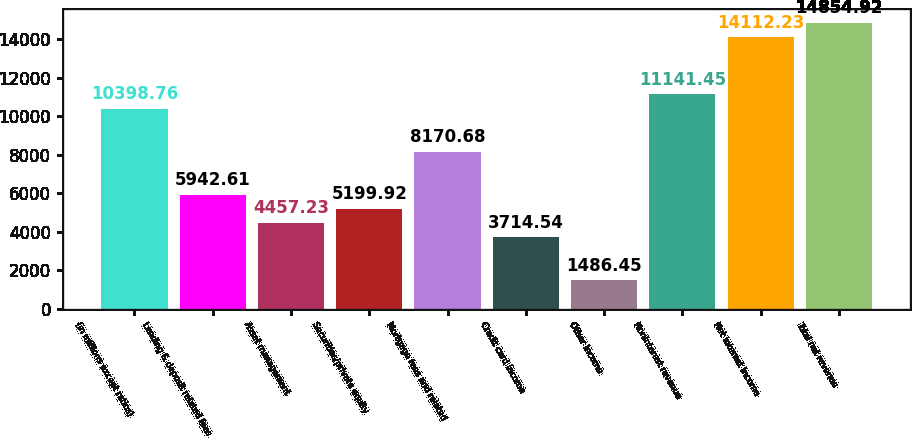<chart> <loc_0><loc_0><loc_500><loc_500><bar_chart><fcel>(in millions except ratios)<fcel>Lending & deposit related fees<fcel>Asset management<fcel>Securities/private equity<fcel>Mortgage fees and related<fcel>Credit card income<fcel>Other income<fcel>Noninterest revenue<fcel>Net interest income<fcel>Total net revenue<nl><fcel>10398.8<fcel>5942.61<fcel>4457.23<fcel>5199.92<fcel>8170.68<fcel>3714.54<fcel>1486.45<fcel>11141.5<fcel>14112.2<fcel>14854.9<nl></chart> 